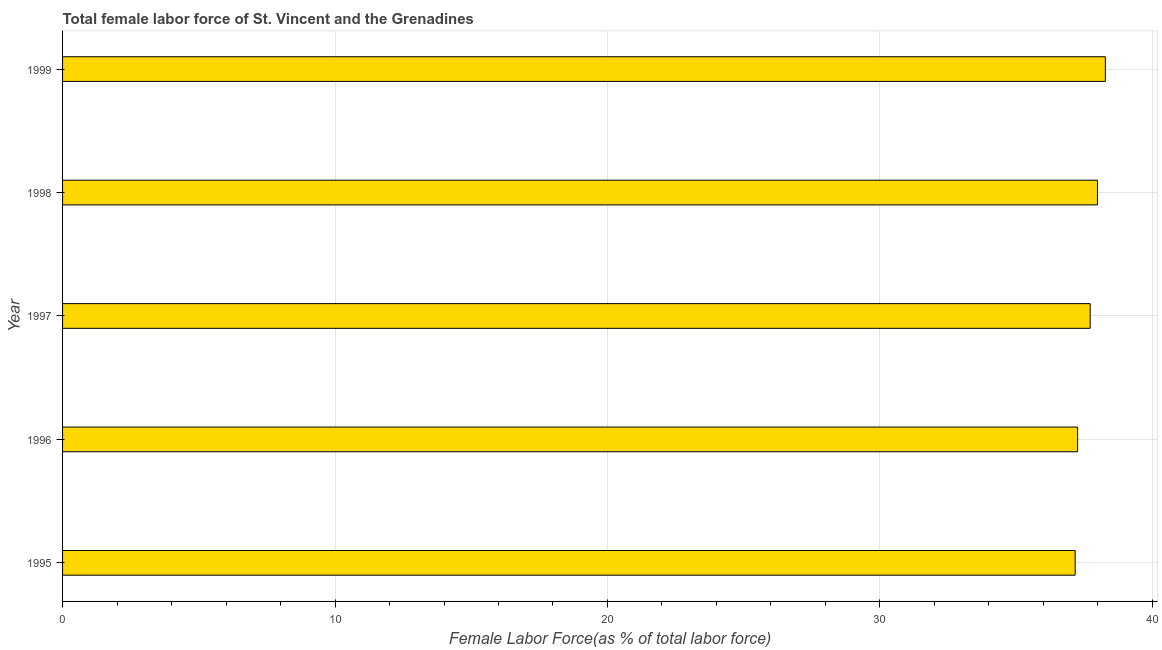Does the graph contain grids?
Give a very brief answer. Yes. What is the title of the graph?
Give a very brief answer. Total female labor force of St. Vincent and the Grenadines. What is the label or title of the X-axis?
Your answer should be compact. Female Labor Force(as % of total labor force). What is the label or title of the Y-axis?
Offer a very short reply. Year. What is the total female labor force in 1998?
Your answer should be very brief. 37.99. Across all years, what is the maximum total female labor force?
Give a very brief answer. 38.27. Across all years, what is the minimum total female labor force?
Provide a short and direct response. 37.17. In which year was the total female labor force maximum?
Ensure brevity in your answer.  1999. What is the sum of the total female labor force?
Provide a succinct answer. 188.4. What is the difference between the total female labor force in 1998 and 1999?
Your answer should be compact. -0.29. What is the average total female labor force per year?
Make the answer very short. 37.68. What is the median total female labor force?
Your answer should be very brief. 37.72. Do a majority of the years between 1999 and 1998 (inclusive) have total female labor force greater than 14 %?
Ensure brevity in your answer.  No. Is the difference between the total female labor force in 1997 and 1998 greater than the difference between any two years?
Keep it short and to the point. No. What is the difference between the highest and the second highest total female labor force?
Make the answer very short. 0.29. What is the difference between the highest and the lowest total female labor force?
Offer a very short reply. 1.11. How many bars are there?
Provide a succinct answer. 5. What is the difference between two consecutive major ticks on the X-axis?
Make the answer very short. 10. Are the values on the major ticks of X-axis written in scientific E-notation?
Give a very brief answer. No. What is the Female Labor Force(as % of total labor force) in 1995?
Keep it short and to the point. 37.17. What is the Female Labor Force(as % of total labor force) in 1996?
Ensure brevity in your answer.  37.26. What is the Female Labor Force(as % of total labor force) in 1997?
Offer a terse response. 37.72. What is the Female Labor Force(as % of total labor force) in 1998?
Make the answer very short. 37.99. What is the Female Labor Force(as % of total labor force) in 1999?
Your answer should be compact. 38.27. What is the difference between the Female Labor Force(as % of total labor force) in 1995 and 1996?
Your response must be concise. -0.09. What is the difference between the Female Labor Force(as % of total labor force) in 1995 and 1997?
Keep it short and to the point. -0.55. What is the difference between the Female Labor Force(as % of total labor force) in 1995 and 1998?
Keep it short and to the point. -0.82. What is the difference between the Female Labor Force(as % of total labor force) in 1995 and 1999?
Keep it short and to the point. -1.11. What is the difference between the Female Labor Force(as % of total labor force) in 1996 and 1997?
Give a very brief answer. -0.46. What is the difference between the Female Labor Force(as % of total labor force) in 1996 and 1998?
Offer a very short reply. -0.73. What is the difference between the Female Labor Force(as % of total labor force) in 1996 and 1999?
Provide a succinct answer. -1.02. What is the difference between the Female Labor Force(as % of total labor force) in 1997 and 1998?
Provide a short and direct response. -0.27. What is the difference between the Female Labor Force(as % of total labor force) in 1997 and 1999?
Your response must be concise. -0.56. What is the difference between the Female Labor Force(as % of total labor force) in 1998 and 1999?
Offer a very short reply. -0.29. What is the ratio of the Female Labor Force(as % of total labor force) in 1996 to that in 1999?
Provide a short and direct response. 0.97. 